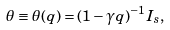Convert formula to latex. <formula><loc_0><loc_0><loc_500><loc_500>\theta \equiv \theta ( q ) = ( 1 - \gamma q ) ^ { - 1 } I _ { s } ,</formula> 